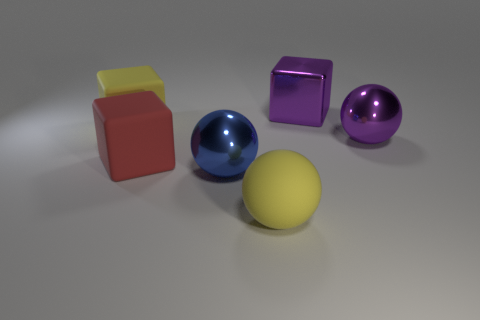What number of yellow matte spheres are the same size as the red thing?
Your response must be concise. 1. What number of large things are matte things or red rubber cubes?
Ensure brevity in your answer.  3. Are there any big gray metal objects?
Give a very brief answer. No. Is the number of metal things that are behind the big blue thing greater than the number of rubber balls in front of the big yellow ball?
Your response must be concise. Yes. What color is the large shiny thing in front of the shiny sphere that is right of the big rubber sphere?
Your answer should be very brief. Blue. Is there another block that has the same color as the big metal cube?
Your answer should be very brief. No. How big is the purple thing left of the purple thing to the right of the big cube to the right of the big blue metallic sphere?
Provide a short and direct response. Large. The large red thing is what shape?
Keep it short and to the point. Cube. There is a ball that is the same color as the big shiny block; what is its size?
Your response must be concise. Large. What number of metal balls are on the right side of the large purple object that is on the right side of the purple metal cube?
Your answer should be very brief. 0. 